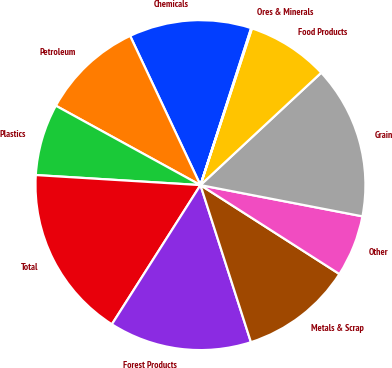Convert chart to OTSL. <chart><loc_0><loc_0><loc_500><loc_500><pie_chart><fcel>Chemicals<fcel>Petroleum<fcel>Plastics<fcel>Total<fcel>Forest Products<fcel>Metals & Scrap<fcel>Other<fcel>Grain<fcel>Food Products<fcel>Ores & Minerals<nl><fcel>11.98%<fcel>10.0%<fcel>7.02%<fcel>16.95%<fcel>13.97%<fcel>10.99%<fcel>6.03%<fcel>14.96%<fcel>8.02%<fcel>0.08%<nl></chart> 